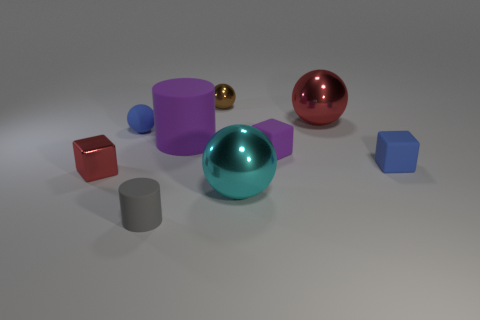Is the number of small balls greater than the number of big cylinders?
Your response must be concise. Yes. How many cubes are tiny objects or small red metallic things?
Provide a short and direct response. 3. What is the color of the tiny rubber ball?
Give a very brief answer. Blue. There is a red metallic object to the right of the purple rubber cylinder; is its size the same as the rubber cylinder behind the small red metallic object?
Your response must be concise. Yes. Are there fewer cyan spheres than tiny brown shiny cylinders?
Make the answer very short. No. What number of cyan shiny objects are left of the gray matte cylinder?
Your response must be concise. 0. What is the tiny brown sphere made of?
Your response must be concise. Metal. Does the tiny rubber cylinder have the same color as the shiny cube?
Ensure brevity in your answer.  No. Is the number of large cyan spheres that are behind the large cyan object less than the number of red metallic blocks?
Offer a terse response. Yes. What is the color of the cube that is to the right of the big red thing?
Make the answer very short. Blue. 